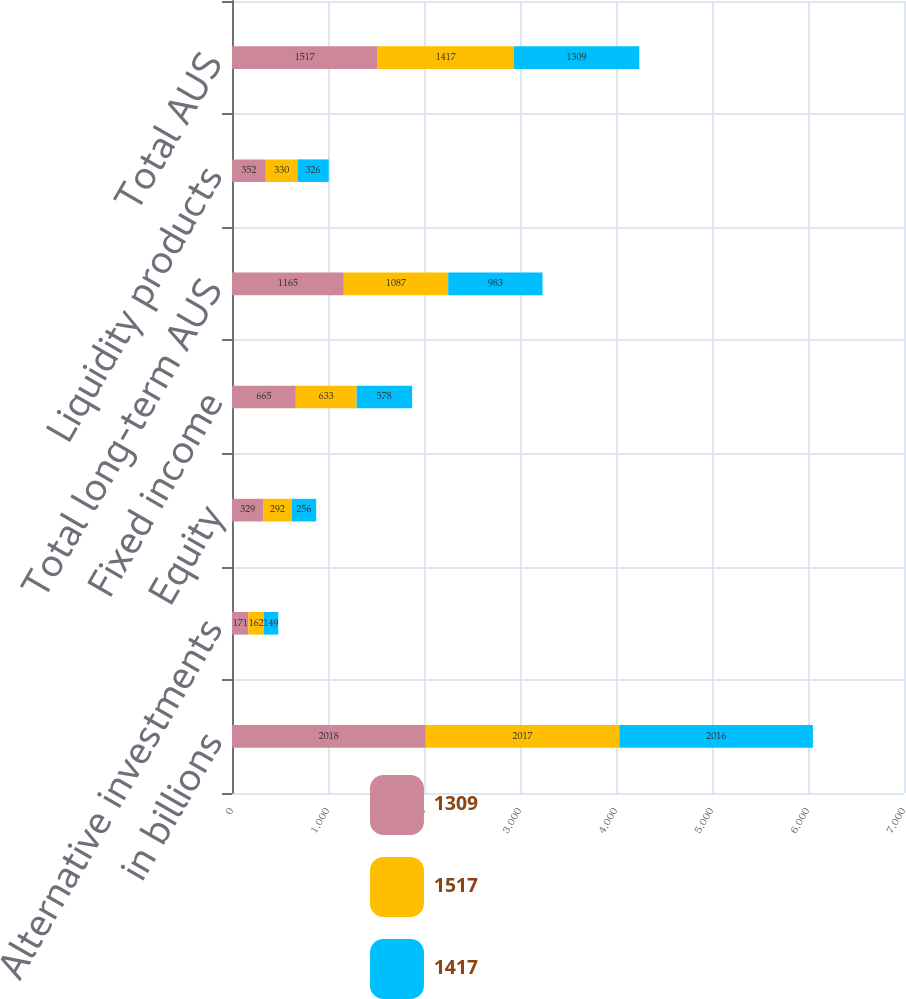Convert chart. <chart><loc_0><loc_0><loc_500><loc_500><stacked_bar_chart><ecel><fcel>in billions<fcel>Alternative investments<fcel>Equity<fcel>Fixed income<fcel>Total long-term AUS<fcel>Liquidity products<fcel>Total AUS<nl><fcel>1309<fcel>2018<fcel>171<fcel>329<fcel>665<fcel>1165<fcel>352<fcel>1517<nl><fcel>1517<fcel>2017<fcel>162<fcel>292<fcel>633<fcel>1087<fcel>330<fcel>1417<nl><fcel>1417<fcel>2016<fcel>149<fcel>256<fcel>578<fcel>983<fcel>326<fcel>1309<nl></chart> 